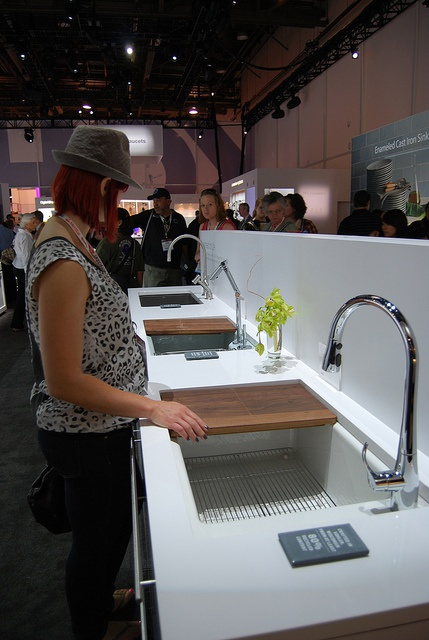Describe the objects in this image and their specific colors. I can see people in black, maroon, and gray tones, sink in black, gray, darkgray, and lightgray tones, people in black, gray, and maroon tones, book in black, gray, darkgray, and lightgray tones, and people in black, gray, maroon, and darkgray tones in this image. 